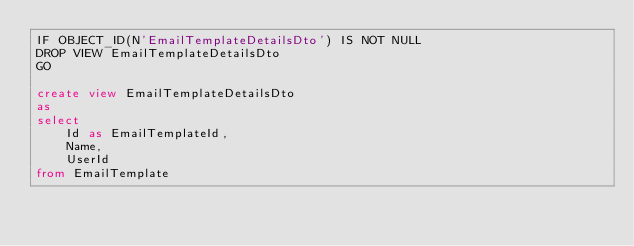Convert code to text. <code><loc_0><loc_0><loc_500><loc_500><_SQL_>IF OBJECT_ID(N'EmailTemplateDetailsDto') IS NOT NULL
DROP VIEW EmailTemplateDetailsDto
GO

create view EmailTemplateDetailsDto
as
select 
	Id as EmailTemplateId,
	Name,
	UserId
from EmailTemplate
</code> 